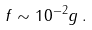Convert formula to latex. <formula><loc_0><loc_0><loc_500><loc_500>f \sim 1 0 ^ { - 2 } g \, .</formula> 